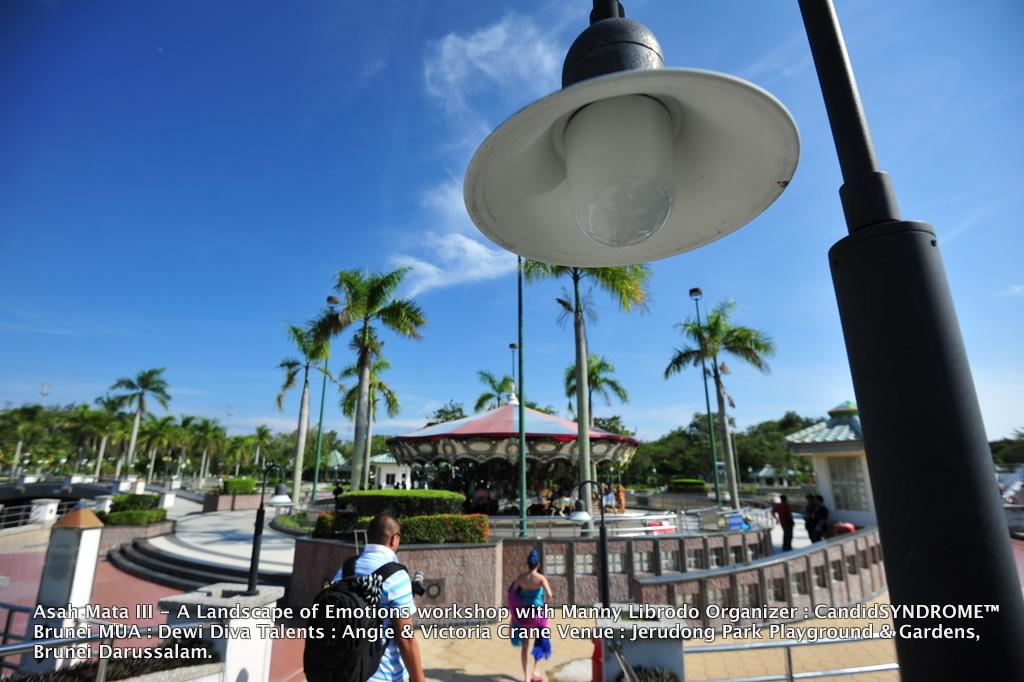How many people are in the image? There are two persons standing on the ground. What is one person wearing in the image? One person is wearing a black bag. What can be seen in the background of the image? There is a carousel, a building, a group of poles, and the sky visible in the background. Are there any chickens running around on the island in the image? There is no island or chickens present in the image. 